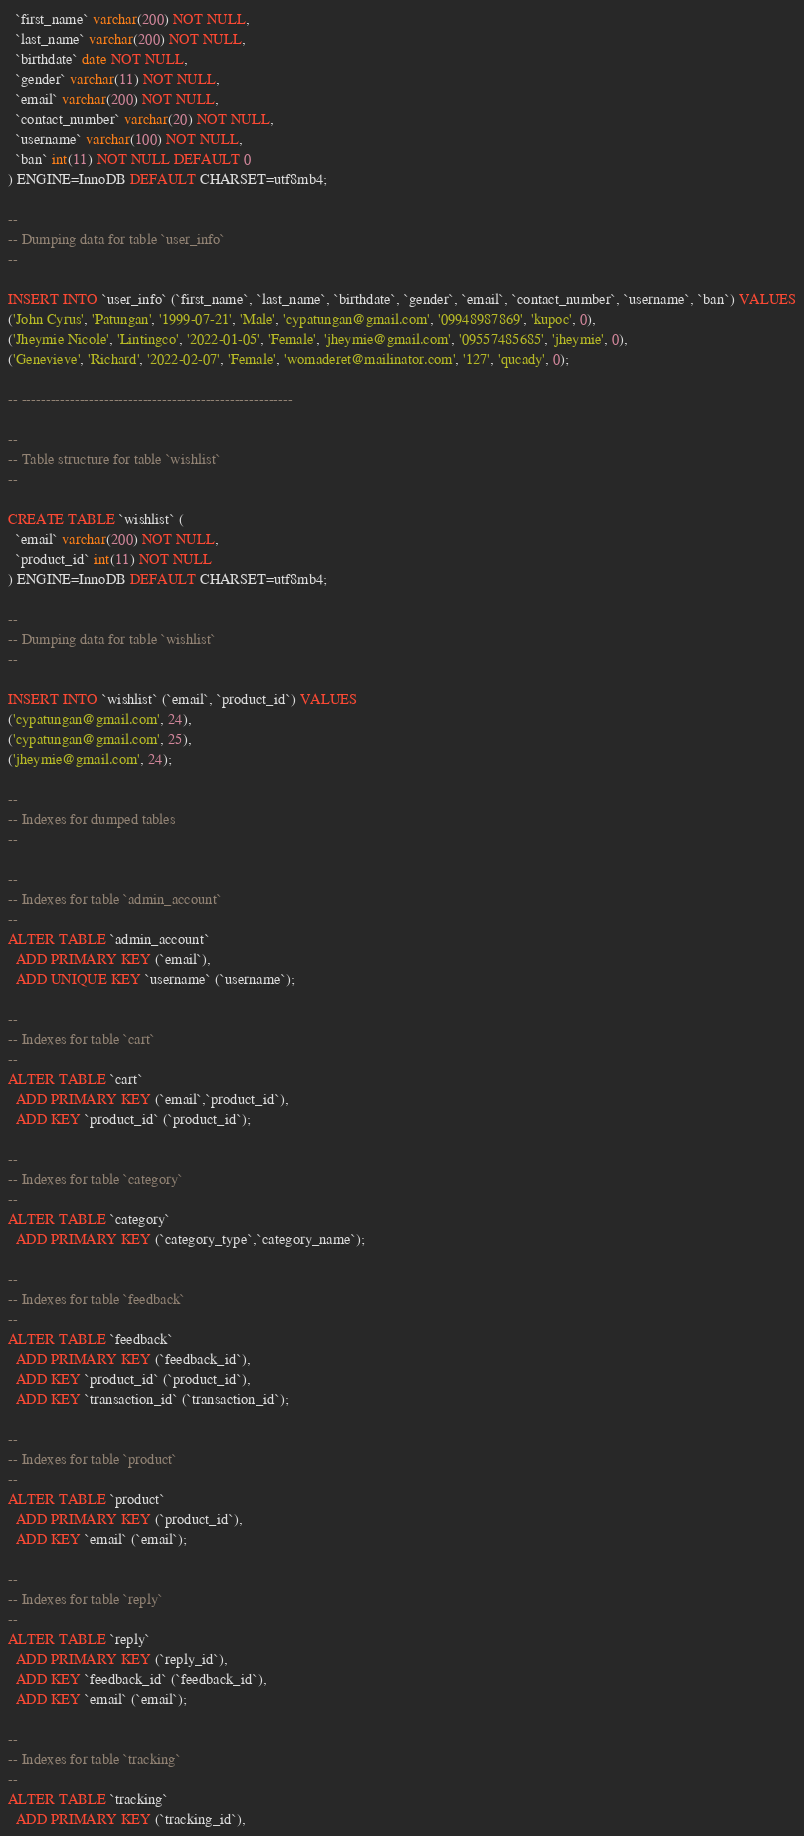<code> <loc_0><loc_0><loc_500><loc_500><_SQL_>  `first_name` varchar(200) NOT NULL,
  `last_name` varchar(200) NOT NULL,
  `birthdate` date NOT NULL,
  `gender` varchar(11) NOT NULL,
  `email` varchar(200) NOT NULL,
  `contact_number` varchar(20) NOT NULL,
  `username` varchar(100) NOT NULL,
  `ban` int(11) NOT NULL DEFAULT 0
) ENGINE=InnoDB DEFAULT CHARSET=utf8mb4;

--
-- Dumping data for table `user_info`
--

INSERT INTO `user_info` (`first_name`, `last_name`, `birthdate`, `gender`, `email`, `contact_number`, `username`, `ban`) VALUES
('John Cyrus', 'Patungan', '1999-07-21', 'Male', 'cypatungan@gmail.com', '09948987869', 'kupoc', 0),
('Jheymie Nicole', 'Lintingco', '2022-01-05', 'Female', 'jheymie@gmail.com', '09557485685', 'jheymie', 0),
('Genevieve', 'Richard', '2022-02-07', 'Female', 'womaderet@mailinator.com', '127', 'qucady', 0);

-- --------------------------------------------------------

--
-- Table structure for table `wishlist`
--

CREATE TABLE `wishlist` (
  `email` varchar(200) NOT NULL,
  `product_id` int(11) NOT NULL
) ENGINE=InnoDB DEFAULT CHARSET=utf8mb4;

--
-- Dumping data for table `wishlist`
--

INSERT INTO `wishlist` (`email`, `product_id`) VALUES
('cypatungan@gmail.com', 24),
('cypatungan@gmail.com', 25),
('jheymie@gmail.com', 24);

--
-- Indexes for dumped tables
--

--
-- Indexes for table `admin_account`
--
ALTER TABLE `admin_account`
  ADD PRIMARY KEY (`email`),
  ADD UNIQUE KEY `username` (`username`);

--
-- Indexes for table `cart`
--
ALTER TABLE `cart`
  ADD PRIMARY KEY (`email`,`product_id`),
  ADD KEY `product_id` (`product_id`);

--
-- Indexes for table `category`
--
ALTER TABLE `category`
  ADD PRIMARY KEY (`category_type`,`category_name`);

--
-- Indexes for table `feedback`
--
ALTER TABLE `feedback`
  ADD PRIMARY KEY (`feedback_id`),
  ADD KEY `product_id` (`product_id`),
  ADD KEY `transaction_id` (`transaction_id`);

--
-- Indexes for table `product`
--
ALTER TABLE `product`
  ADD PRIMARY KEY (`product_id`),
  ADD KEY `email` (`email`);

--
-- Indexes for table `reply`
--
ALTER TABLE `reply`
  ADD PRIMARY KEY (`reply_id`),
  ADD KEY `feedback_id` (`feedback_id`),
  ADD KEY `email` (`email`);

--
-- Indexes for table `tracking`
--
ALTER TABLE `tracking`
  ADD PRIMARY KEY (`tracking_id`),</code> 